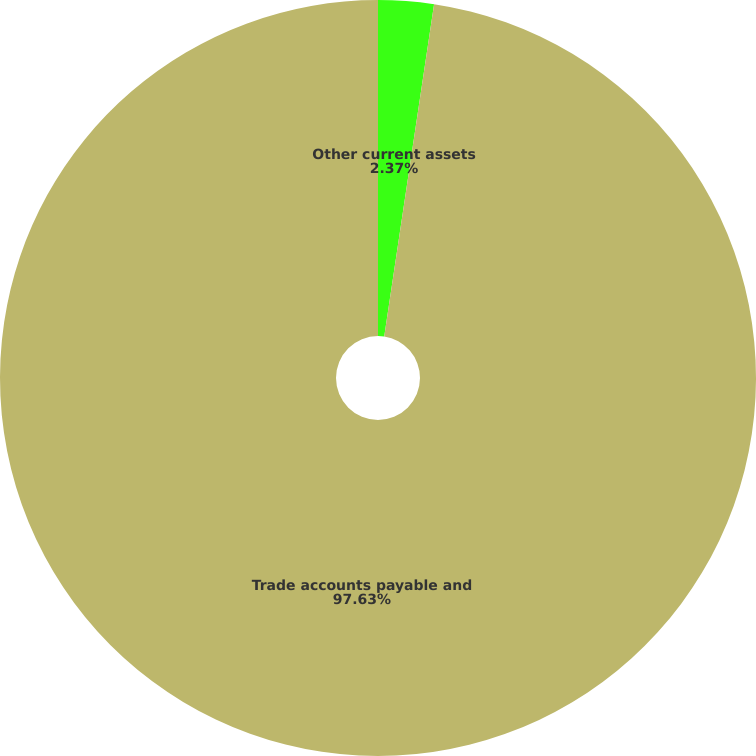Convert chart to OTSL. <chart><loc_0><loc_0><loc_500><loc_500><pie_chart><fcel>Other current assets<fcel>Trade accounts payable and<nl><fcel>2.37%<fcel>97.63%<nl></chart> 